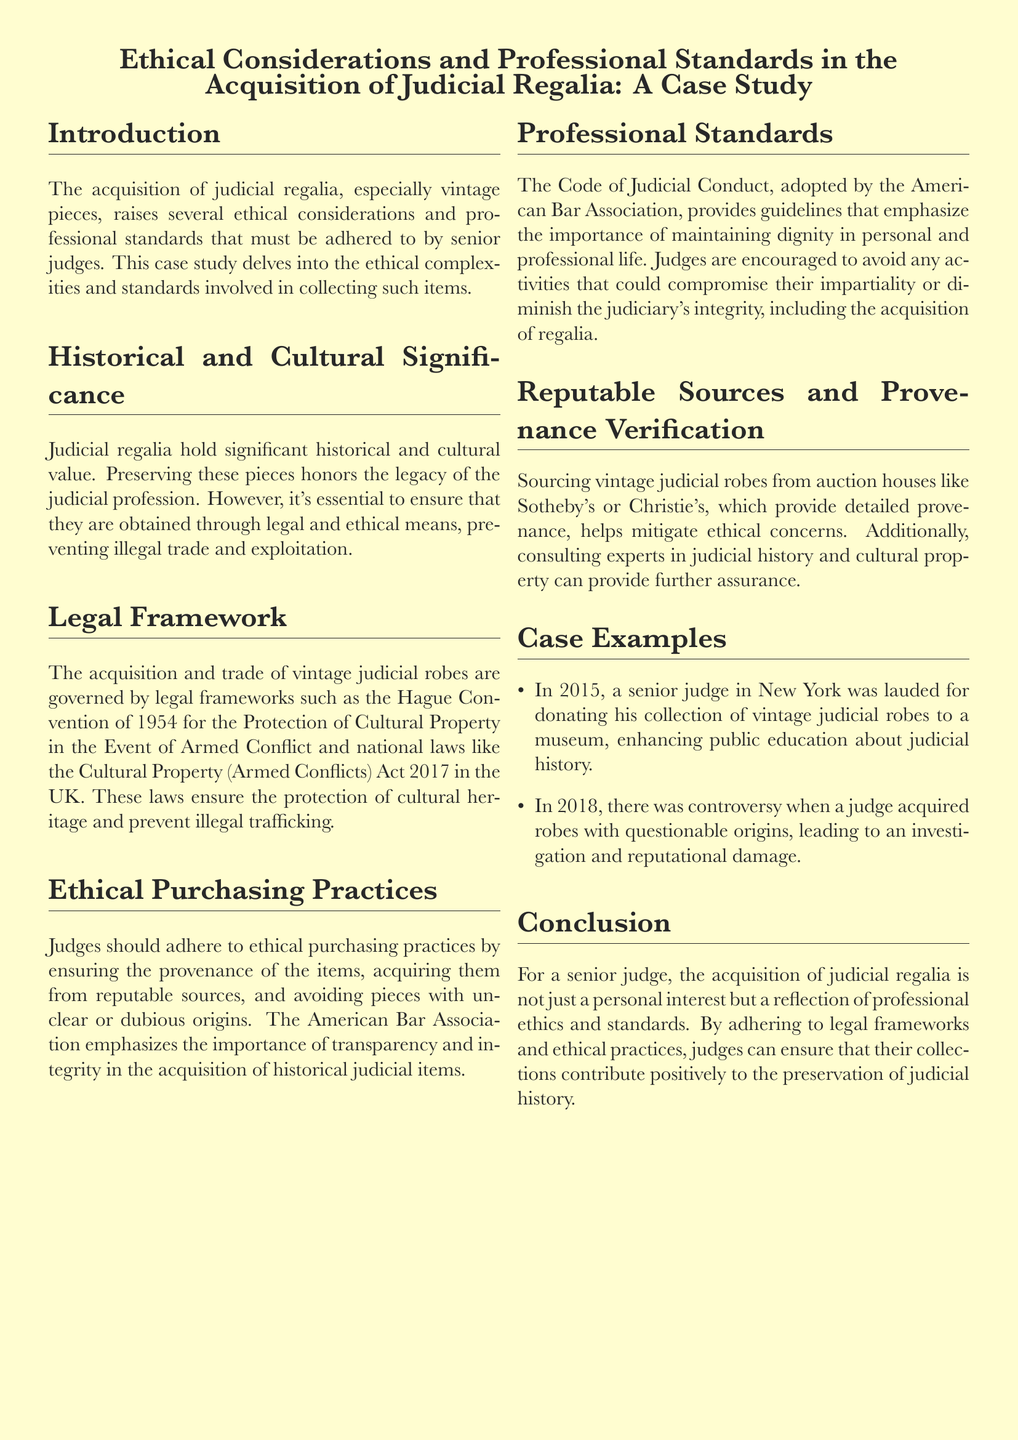What is the main focus of the case study? The case study focuses on ethical considerations and professional standards in the acquisition of judicial regalia.
Answer: Ethical considerations and professional standards in the acquisition of judicial regalia What legal framework is mentioned for the protection of cultural property? The document cites the Hague Convention of 1954 for the Protection of Cultural Property.
Answer: The Hague Convention of 1954 In which year did the controversy over a judge acquiring robes occur? The controversy regarding a judge's acquisition of robes with questionable origins happened in 2018.
Answer: 2018 What does the American Bar Association emphasize regarding purchasing practices? The American Bar Association emphasizes the importance of transparency and integrity in the acquisition of historical judicial items.
Answer: Transparency and integrity What example is given of a positive outcome related to judicial regalia? A senior judge in New York was lauded for donating his collection of vintage judicial robes to a museum.
Answer: Donating his collection to a museum Which two auction houses are recommended for sourcing vintage judicial robes? The document recommends sourcing vintage judicial robes from Sotheby's or Christie's.
Answer: Sotheby's or Christie's What is the result of acquiring items with unclear origins, as mentioned in the case study? Acquiring items with unclear origins can lead to investigations and reputational damage.
Answer: Investigations and reputational damage What is encouraged by the Code of Judicial Conduct regarding judges’ activities? The Code encourages judges to avoid activities that could compromise impartiality or diminish the judiciary's integrity.
Answer: Avoid activities that compromise impartiality 